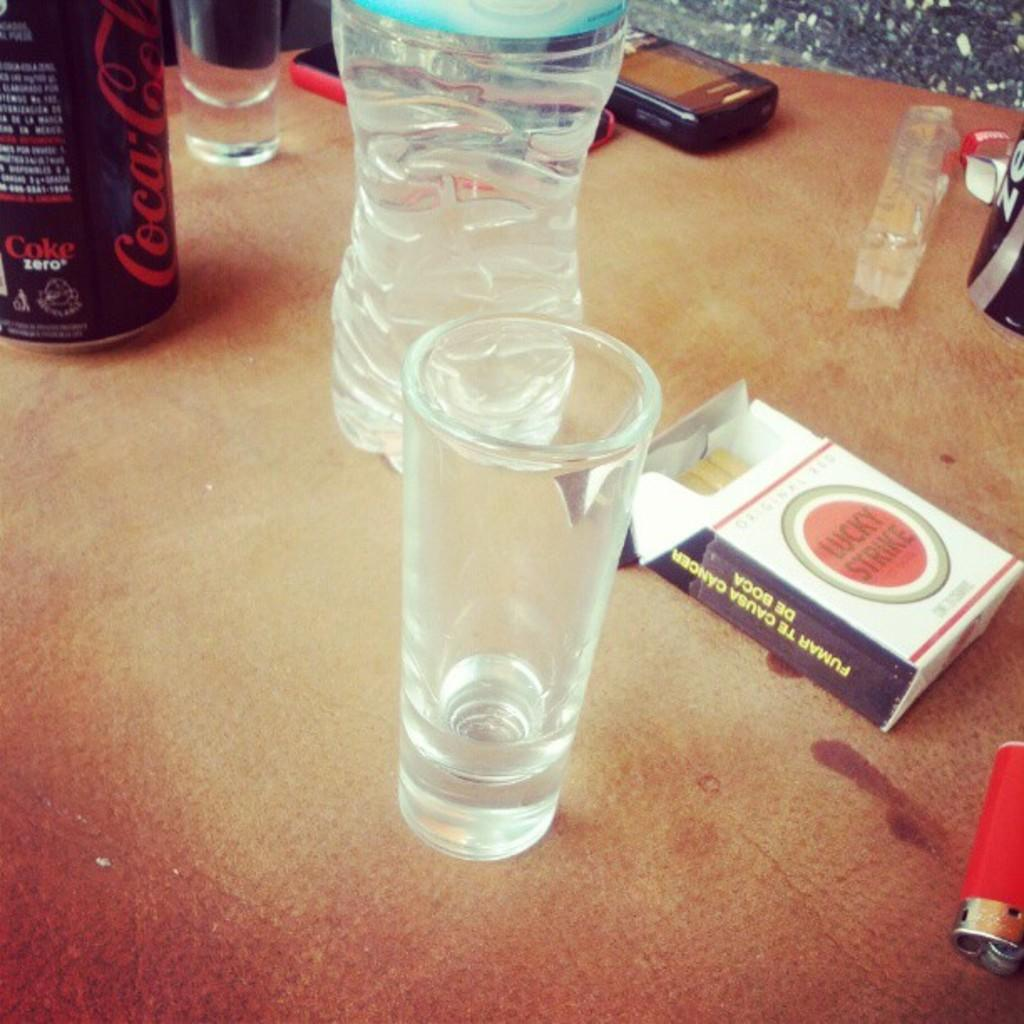Provide a one-sentence caption for the provided image. A table which includes a pack with three cigarettes of Lucky Strike with a red lighter next to it along with a Coke can and various other objects. 